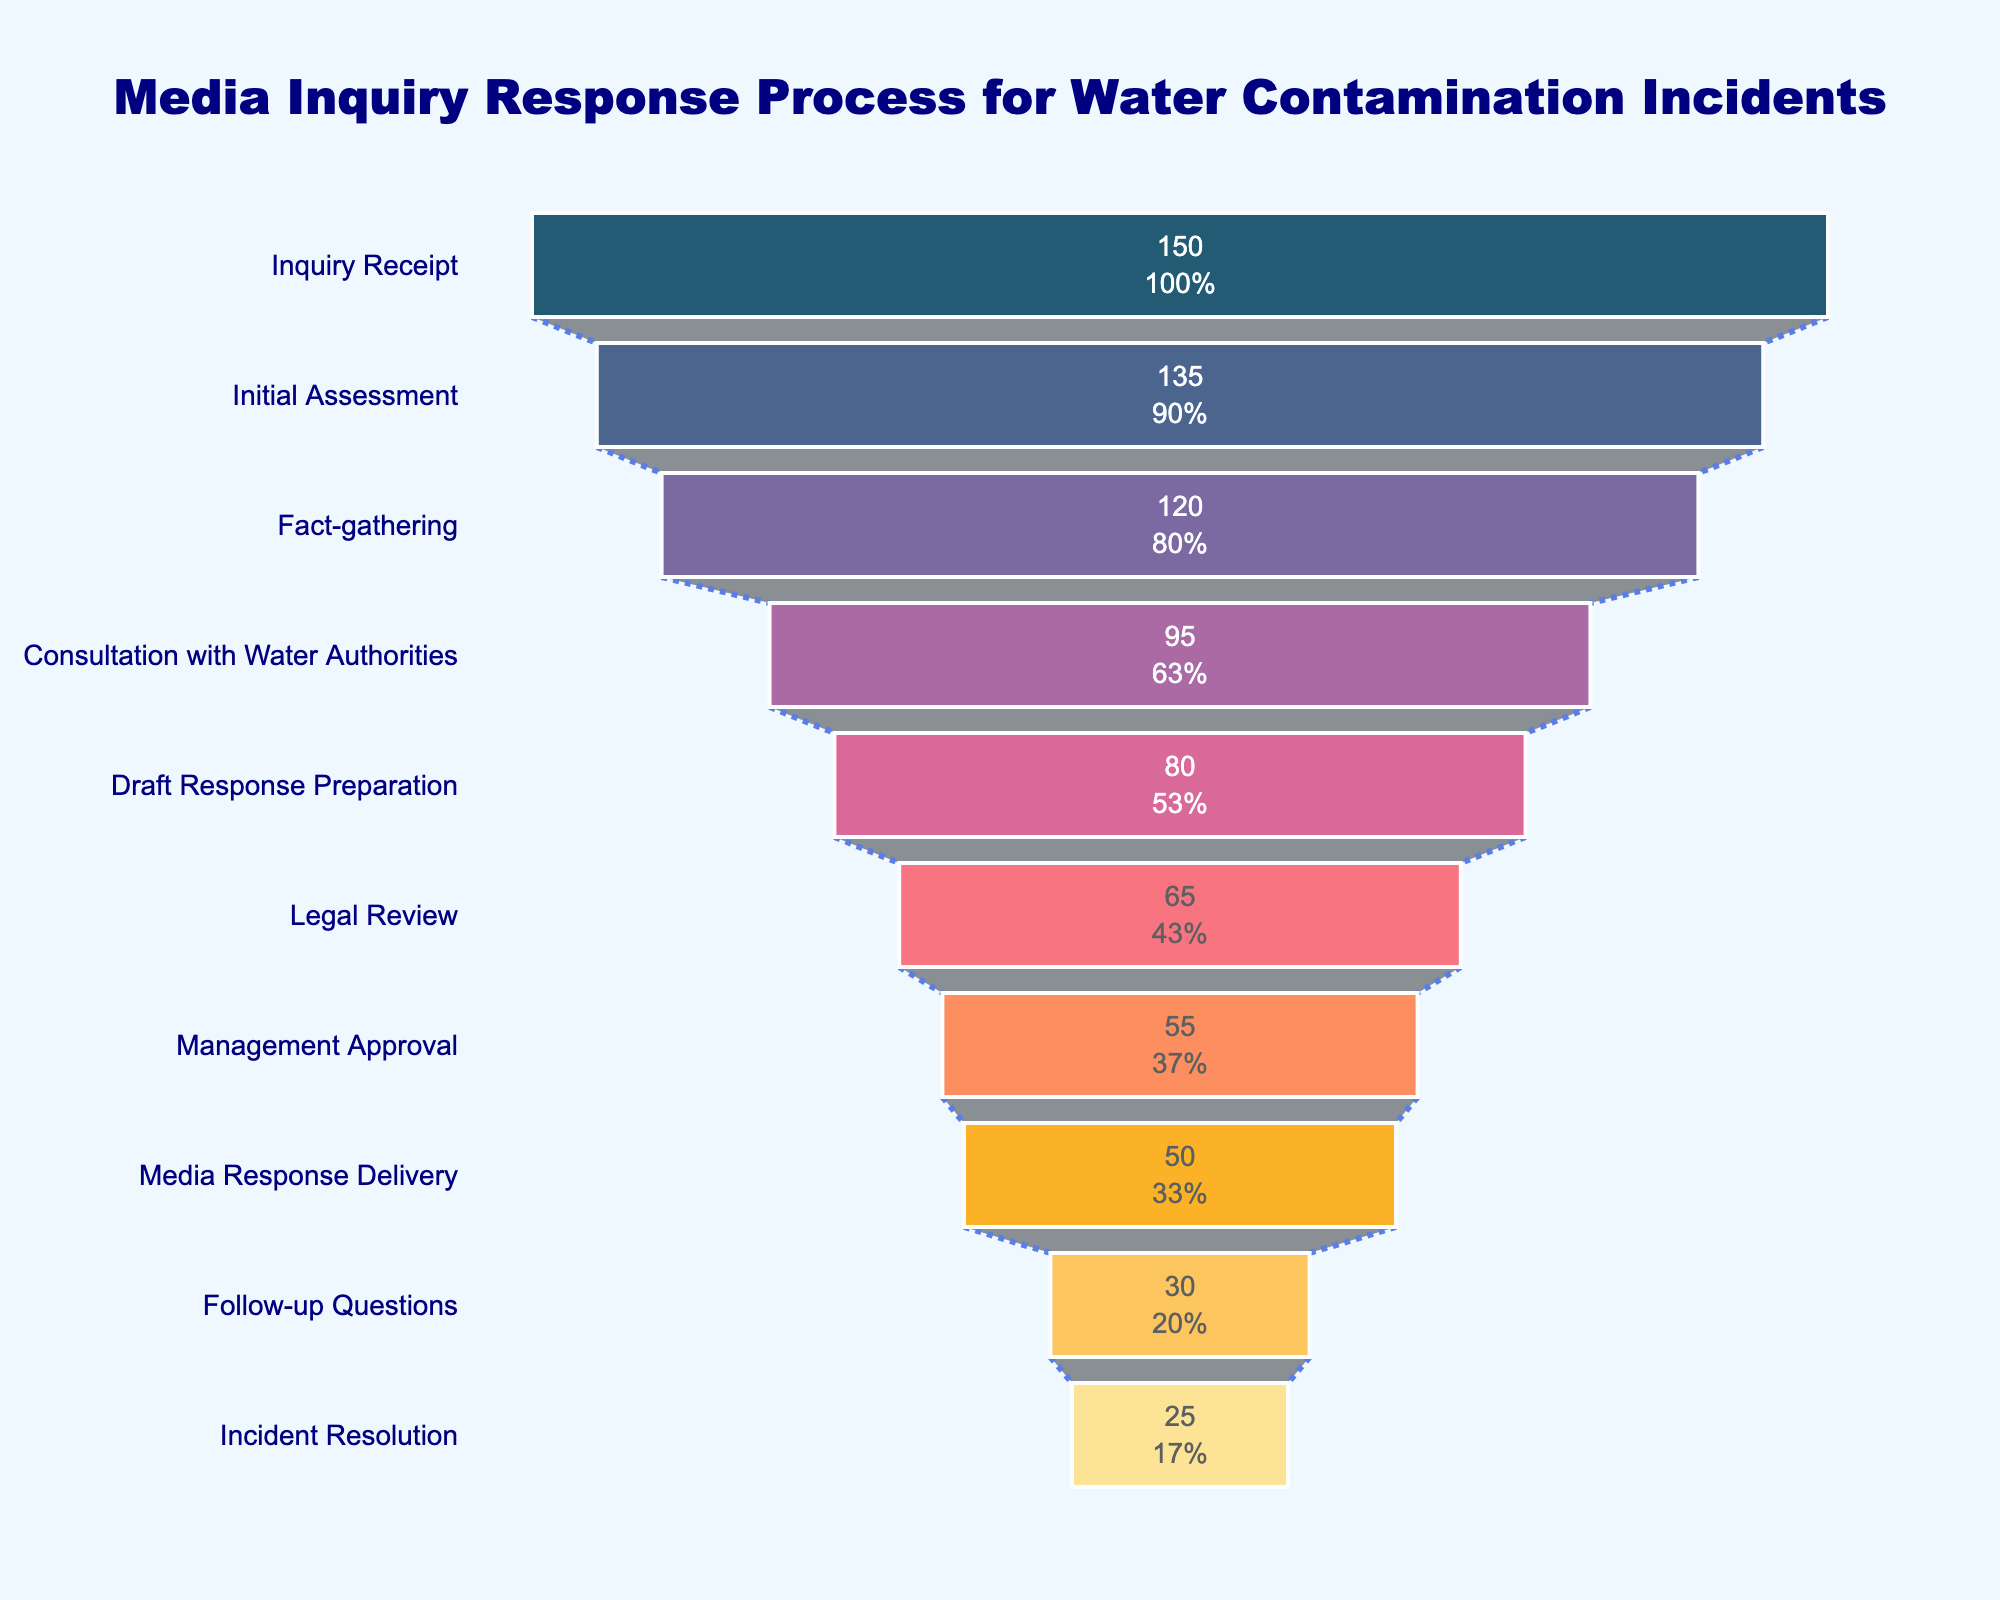What's the title of the figure? The figure's title is located at the top and usually provides an overview of the chart's subject matter. It reads: "Media Inquiry Response Process for Water Contamination Incidents".
Answer: Media Inquiry Response Process for Water Contamination Incidents What stage has the highest number of inquiries? To determine this, look at the first bar in the funnel chart, as it represents the initial stage with the highest number. This stage is labeled "Inquiry Receipt".
Answer: Inquiry Receipt How many inquiries reach the stage "Consultation with Water Authorities"? Find the bar labeled "Consultation with Water Authorities" and observe the text inside this bar which indicates the number of inquiries. It shows 95 inquiries.
Answer: 95 What is the percentage loss of inquiries from "Initial Assessment" to "Fact-gathering"? To find the percentage loss, subtract the number of inquiries at "Fact-gathering" from "Initial Assessment" and then divide by the number of inquiries at "Initial Assessment", finally multiply by 100. ((135-120)/135)*100 = 11.1%.
Answer: 11.1% How many more inquiries reach the stage "Media Response Delivery" compared to "Legal Review"? Find the numbers for "Media Response Delivery" and "Legal Review", which are 50 and 65 respectively. Subtract the number of inquiries at "Legal Review" from "Media Response Delivery": 65 - 50 = 15.
Answer: 15 What is the final stage in the media inquiry response process? The final stage is the last labeled bar at the bottom of the funnel chart. It reads: "Incident Resolution".
Answer: Incident Resolution What is the cumulative percentage of inquiries remaining from "Inquiry Receipt" to "Management Approval"? Calculate the cumulative percentage by dividing the number of inquiries at "Management Approval" by the initial number of inquiries and multiplying by 100. (55/150)*100 = 36.7%.
Answer: 36.7% Which stage sees the highest drop in the number of inquiries? Compare the differences between successive stages. The largest drop is between "Fact-gathering" and "Consultation with Water Authorities" (120 - 95 = 25).
Answer: Between Fact-gathering and Consultation with Water Authorities How many inquiries are lost between "Draft Response Preparation" and "Legal Review"? Subtract the number of inquiries at "Legal Review" from those at "Draft Response Preparation". 80 - 65 = 15.
Answer: 15 What stage directly follows "Fact-gathering"? Look at the sequence of stages in the chart; the stage immediately after "Fact-gathering" is "Consultation with Water Authorities".
Answer: Consultation with Water Authorities 